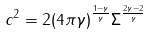Convert formula to latex. <formula><loc_0><loc_0><loc_500><loc_500>c ^ { 2 } = 2 ( 4 \pi \gamma ) ^ { \frac { 1 - \gamma } { \gamma } } \Sigma ^ { \frac { 2 \gamma - 2 } { \gamma } }</formula> 